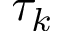Convert formula to latex. <formula><loc_0><loc_0><loc_500><loc_500>\tau _ { k }</formula> 